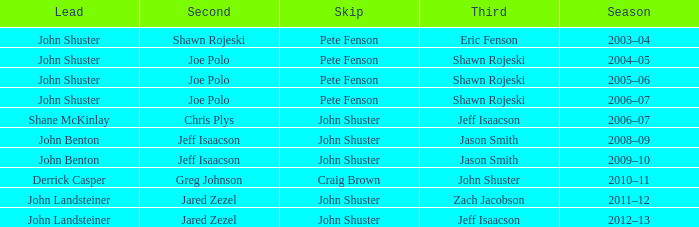Who was the lead with John Shuster as skip in the season of 2009–10? John Benton. 